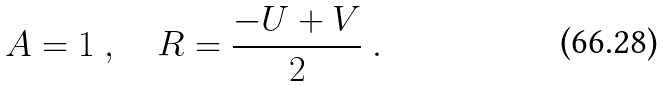Convert formula to latex. <formula><loc_0><loc_0><loc_500><loc_500>A = 1 \ , \quad R = \frac { - U + V } { 2 } \ .</formula> 